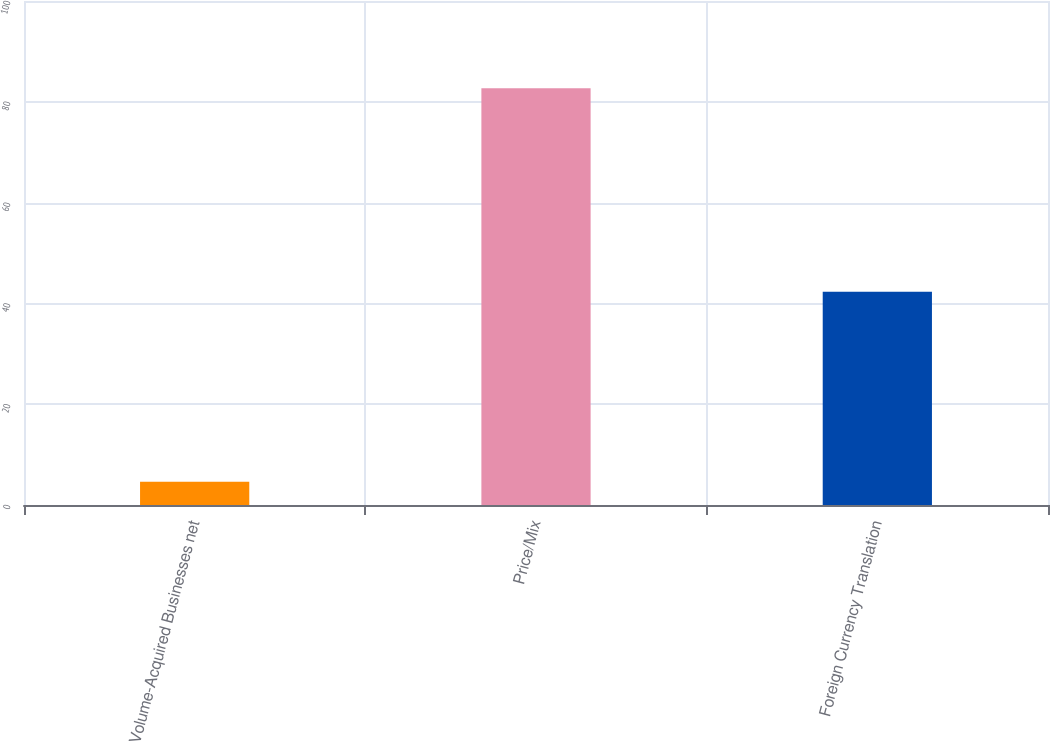Convert chart. <chart><loc_0><loc_0><loc_500><loc_500><bar_chart><fcel>Volume-Acquired Businesses net<fcel>Price/Mix<fcel>Foreign Currency Translation<nl><fcel>4.6<fcel>82.7<fcel>42.3<nl></chart> 